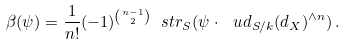<formula> <loc_0><loc_0><loc_500><loc_500>\beta ( \psi ) = \frac { 1 } { n ! } ( - 1 ) ^ { \binom { n - 1 } { 2 } } \ s t r _ { S } ( \psi \cdot \ u d _ { S / k } ( d _ { X } ) ^ { \wedge n } ) \, .</formula> 